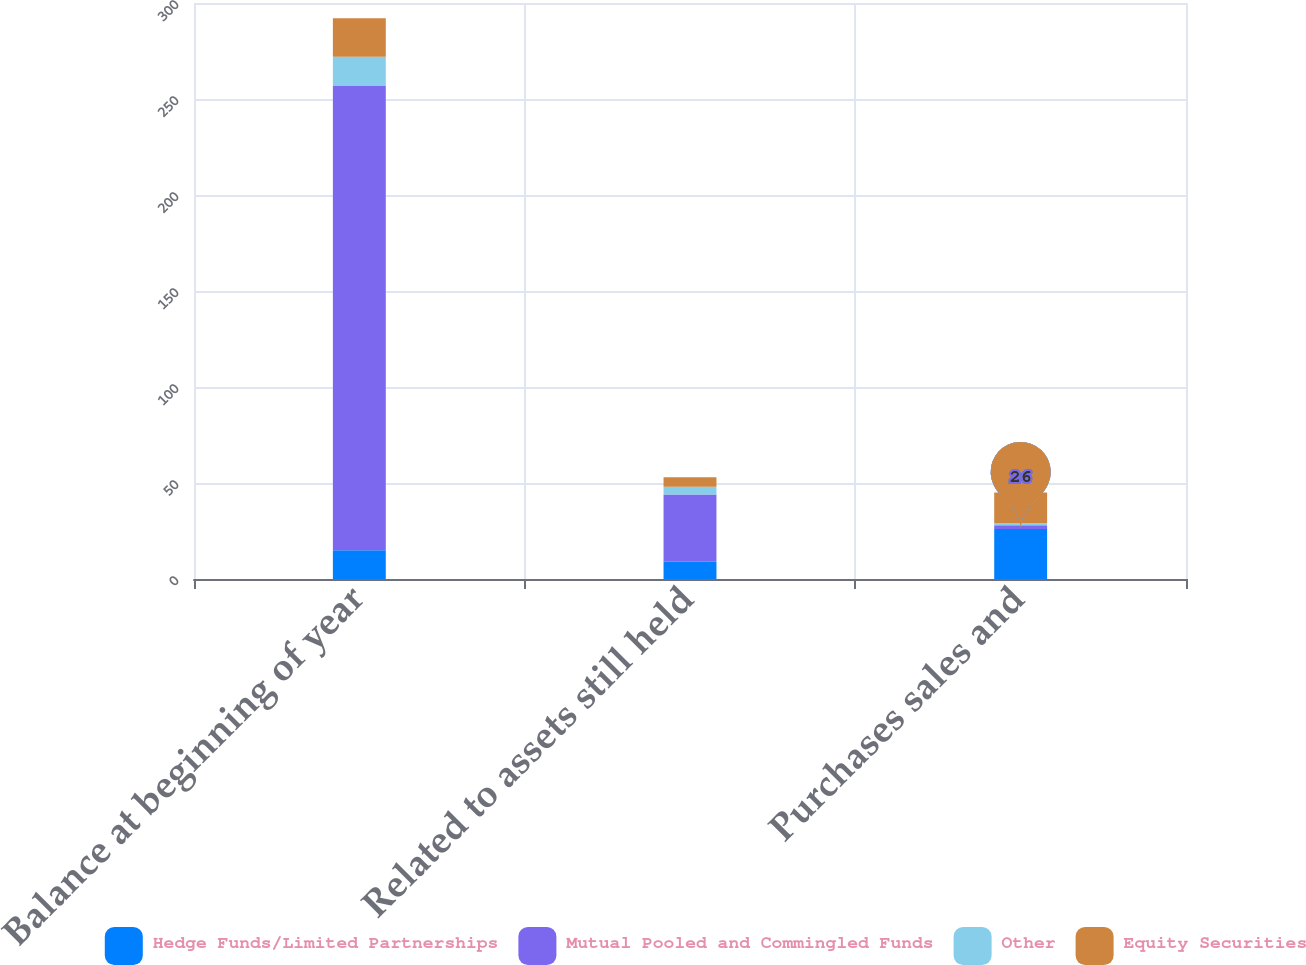<chart> <loc_0><loc_0><loc_500><loc_500><stacked_bar_chart><ecel><fcel>Balance at beginning of year<fcel>Related to assets still held<fcel>Purchases sales and<nl><fcel>Hedge Funds/Limited Partnerships<fcel>15<fcel>9<fcel>26<nl><fcel>Mutual Pooled and Commingled Funds<fcel>242<fcel>35<fcel>2<nl><fcel>Other<fcel>15<fcel>4<fcel>1<nl><fcel>Equity Securities<fcel>20<fcel>5<fcel>16<nl></chart> 